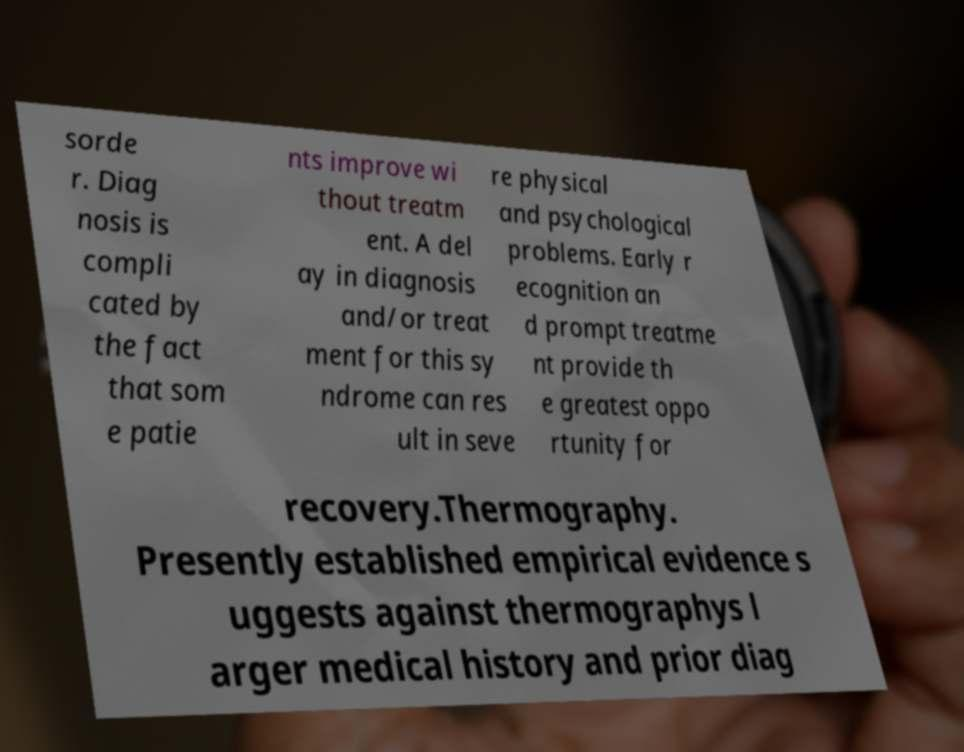Can you accurately transcribe the text from the provided image for me? sorde r. Diag nosis is compli cated by the fact that som e patie nts improve wi thout treatm ent. A del ay in diagnosis and/or treat ment for this sy ndrome can res ult in seve re physical and psychological problems. Early r ecognition an d prompt treatme nt provide th e greatest oppo rtunity for recovery.Thermography. Presently established empirical evidence s uggests against thermographys l arger medical history and prior diag 